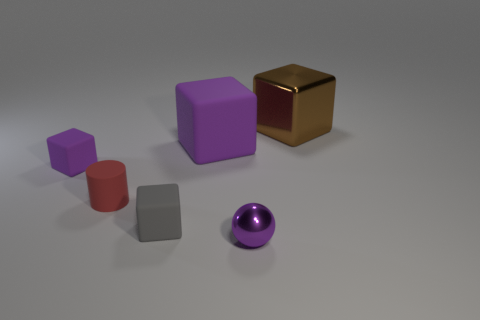Are there any big brown blocks that have the same material as the large purple block?
Provide a short and direct response. No. Does the purple sphere have the same material as the large brown block?
Make the answer very short. Yes. How many brown things are either matte things or large cubes?
Keep it short and to the point. 1. Is the number of cylinders that are in front of the tiny red object greater than the number of big green metal balls?
Your answer should be compact. No. Is there a small matte cube that has the same color as the metallic sphere?
Offer a very short reply. Yes. The metal sphere has what size?
Ensure brevity in your answer.  Small. Is the large matte thing the same color as the cylinder?
Ensure brevity in your answer.  No. What number of things are either brown blocks or blocks on the left side of the small metallic thing?
Provide a short and direct response. 4. Is the number of tiny cyan metal spheres the same as the number of metallic cubes?
Provide a succinct answer. No. There is a tiny purple object that is on the left side of the metallic object that is in front of the large brown block; how many large metal things are to the left of it?
Keep it short and to the point. 0. 